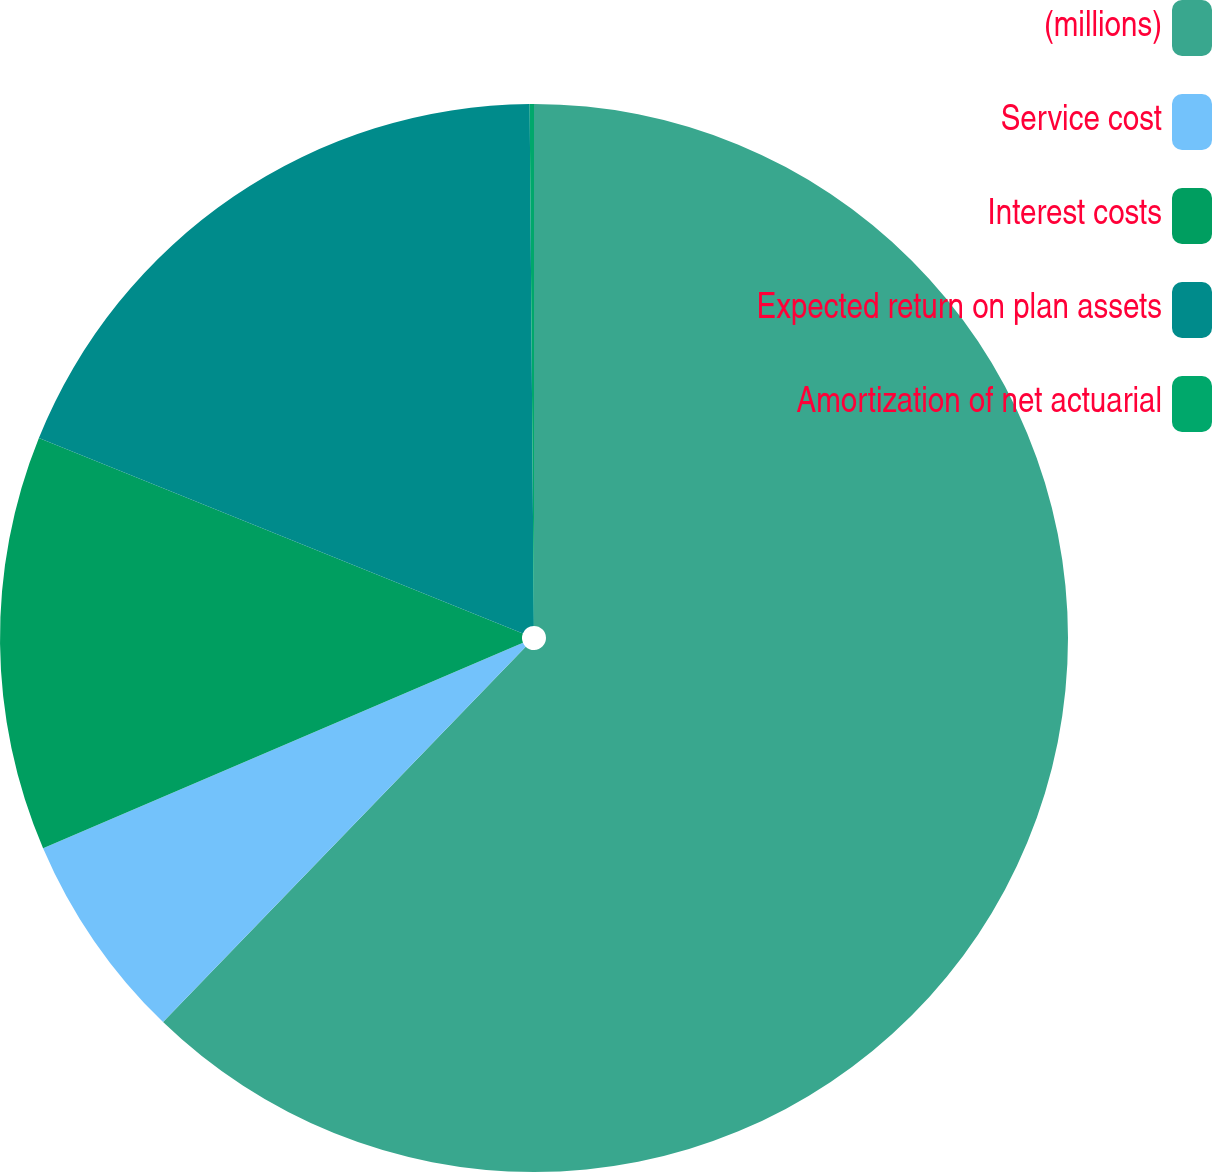<chart> <loc_0><loc_0><loc_500><loc_500><pie_chart><fcel>(millions)<fcel>Service cost<fcel>Interest costs<fcel>Expected return on plan assets<fcel>Amortization of net actuarial<nl><fcel>62.23%<fcel>6.34%<fcel>12.55%<fcel>18.76%<fcel>0.13%<nl></chart> 